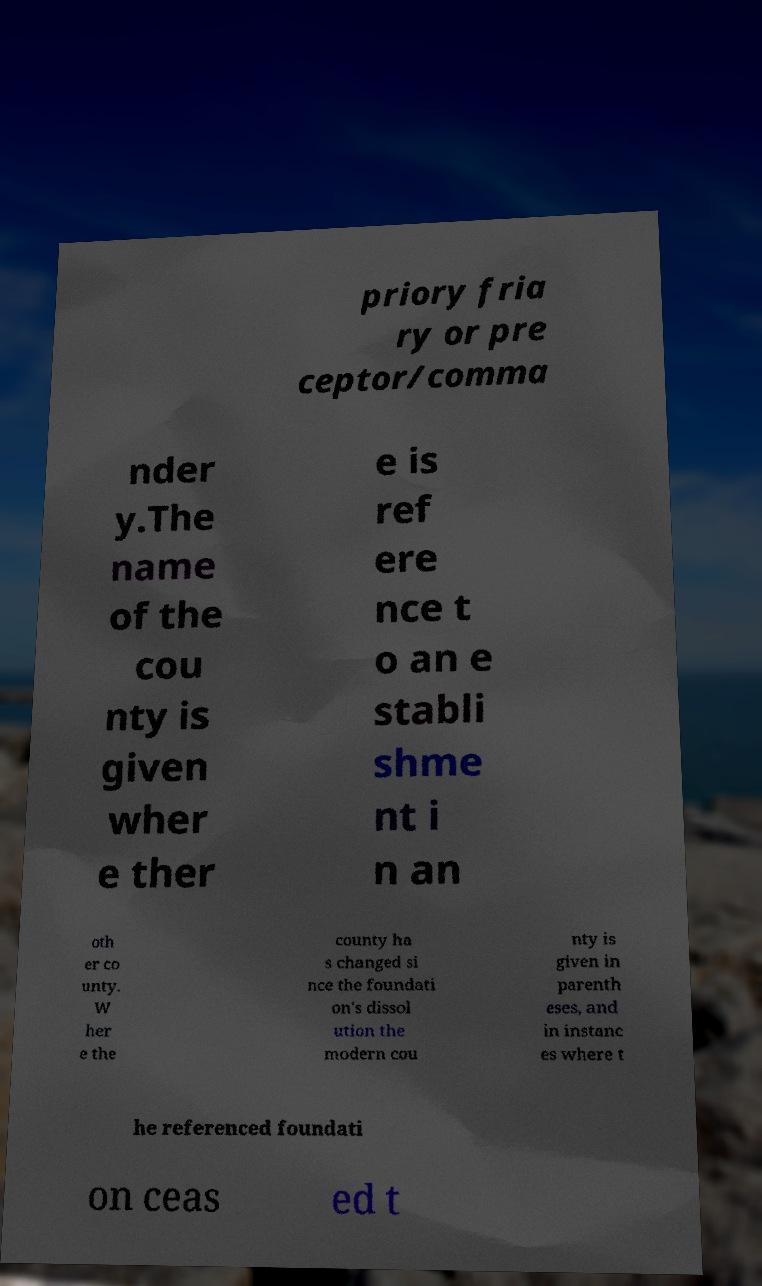There's text embedded in this image that I need extracted. Can you transcribe it verbatim? priory fria ry or pre ceptor/comma nder y.The name of the cou nty is given wher e ther e is ref ere nce t o an e stabli shme nt i n an oth er co unty. W her e the county ha s changed si nce the foundati on's dissol ution the modern cou nty is given in parenth eses, and in instanc es where t he referenced foundati on ceas ed t 